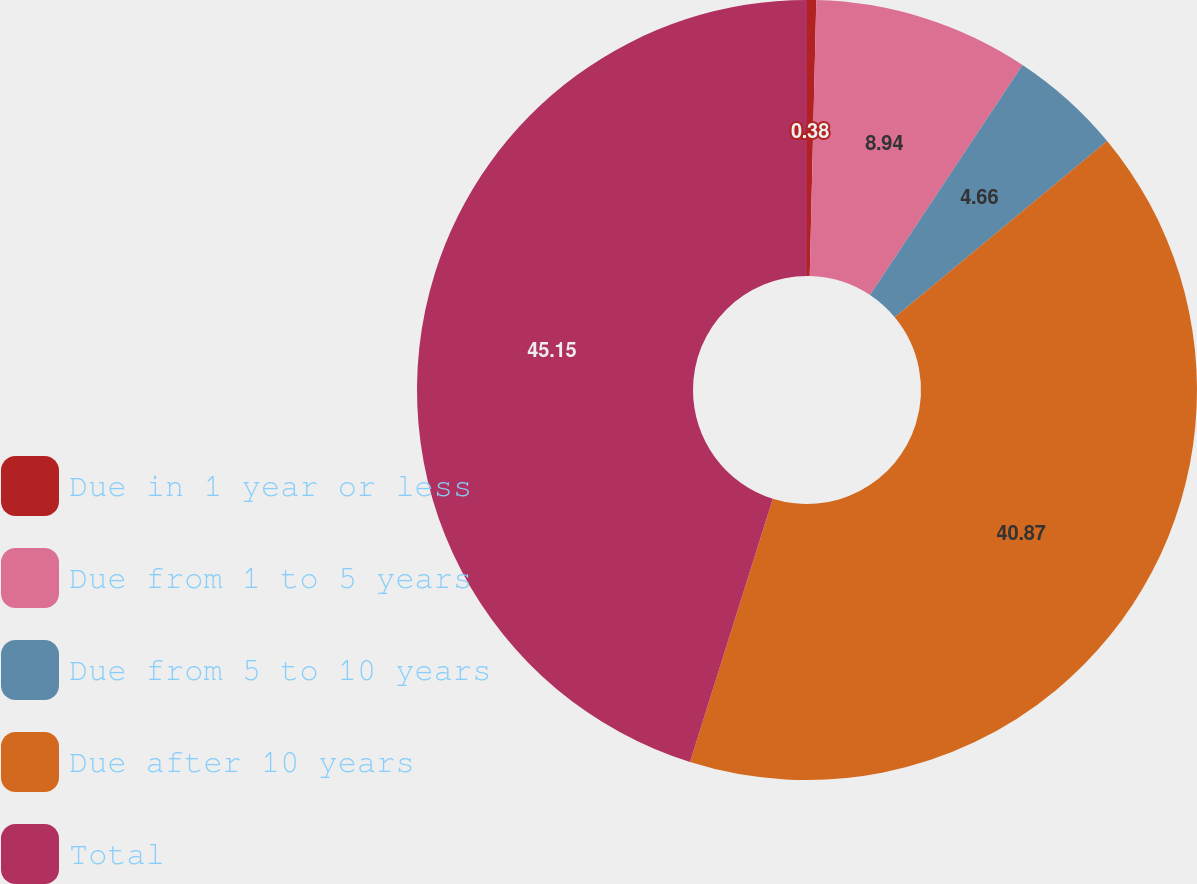<chart> <loc_0><loc_0><loc_500><loc_500><pie_chart><fcel>Due in 1 year or less<fcel>Due from 1 to 5 years<fcel>Due from 5 to 10 years<fcel>Due after 10 years<fcel>Total<nl><fcel>0.38%<fcel>8.94%<fcel>4.66%<fcel>40.87%<fcel>45.15%<nl></chart> 